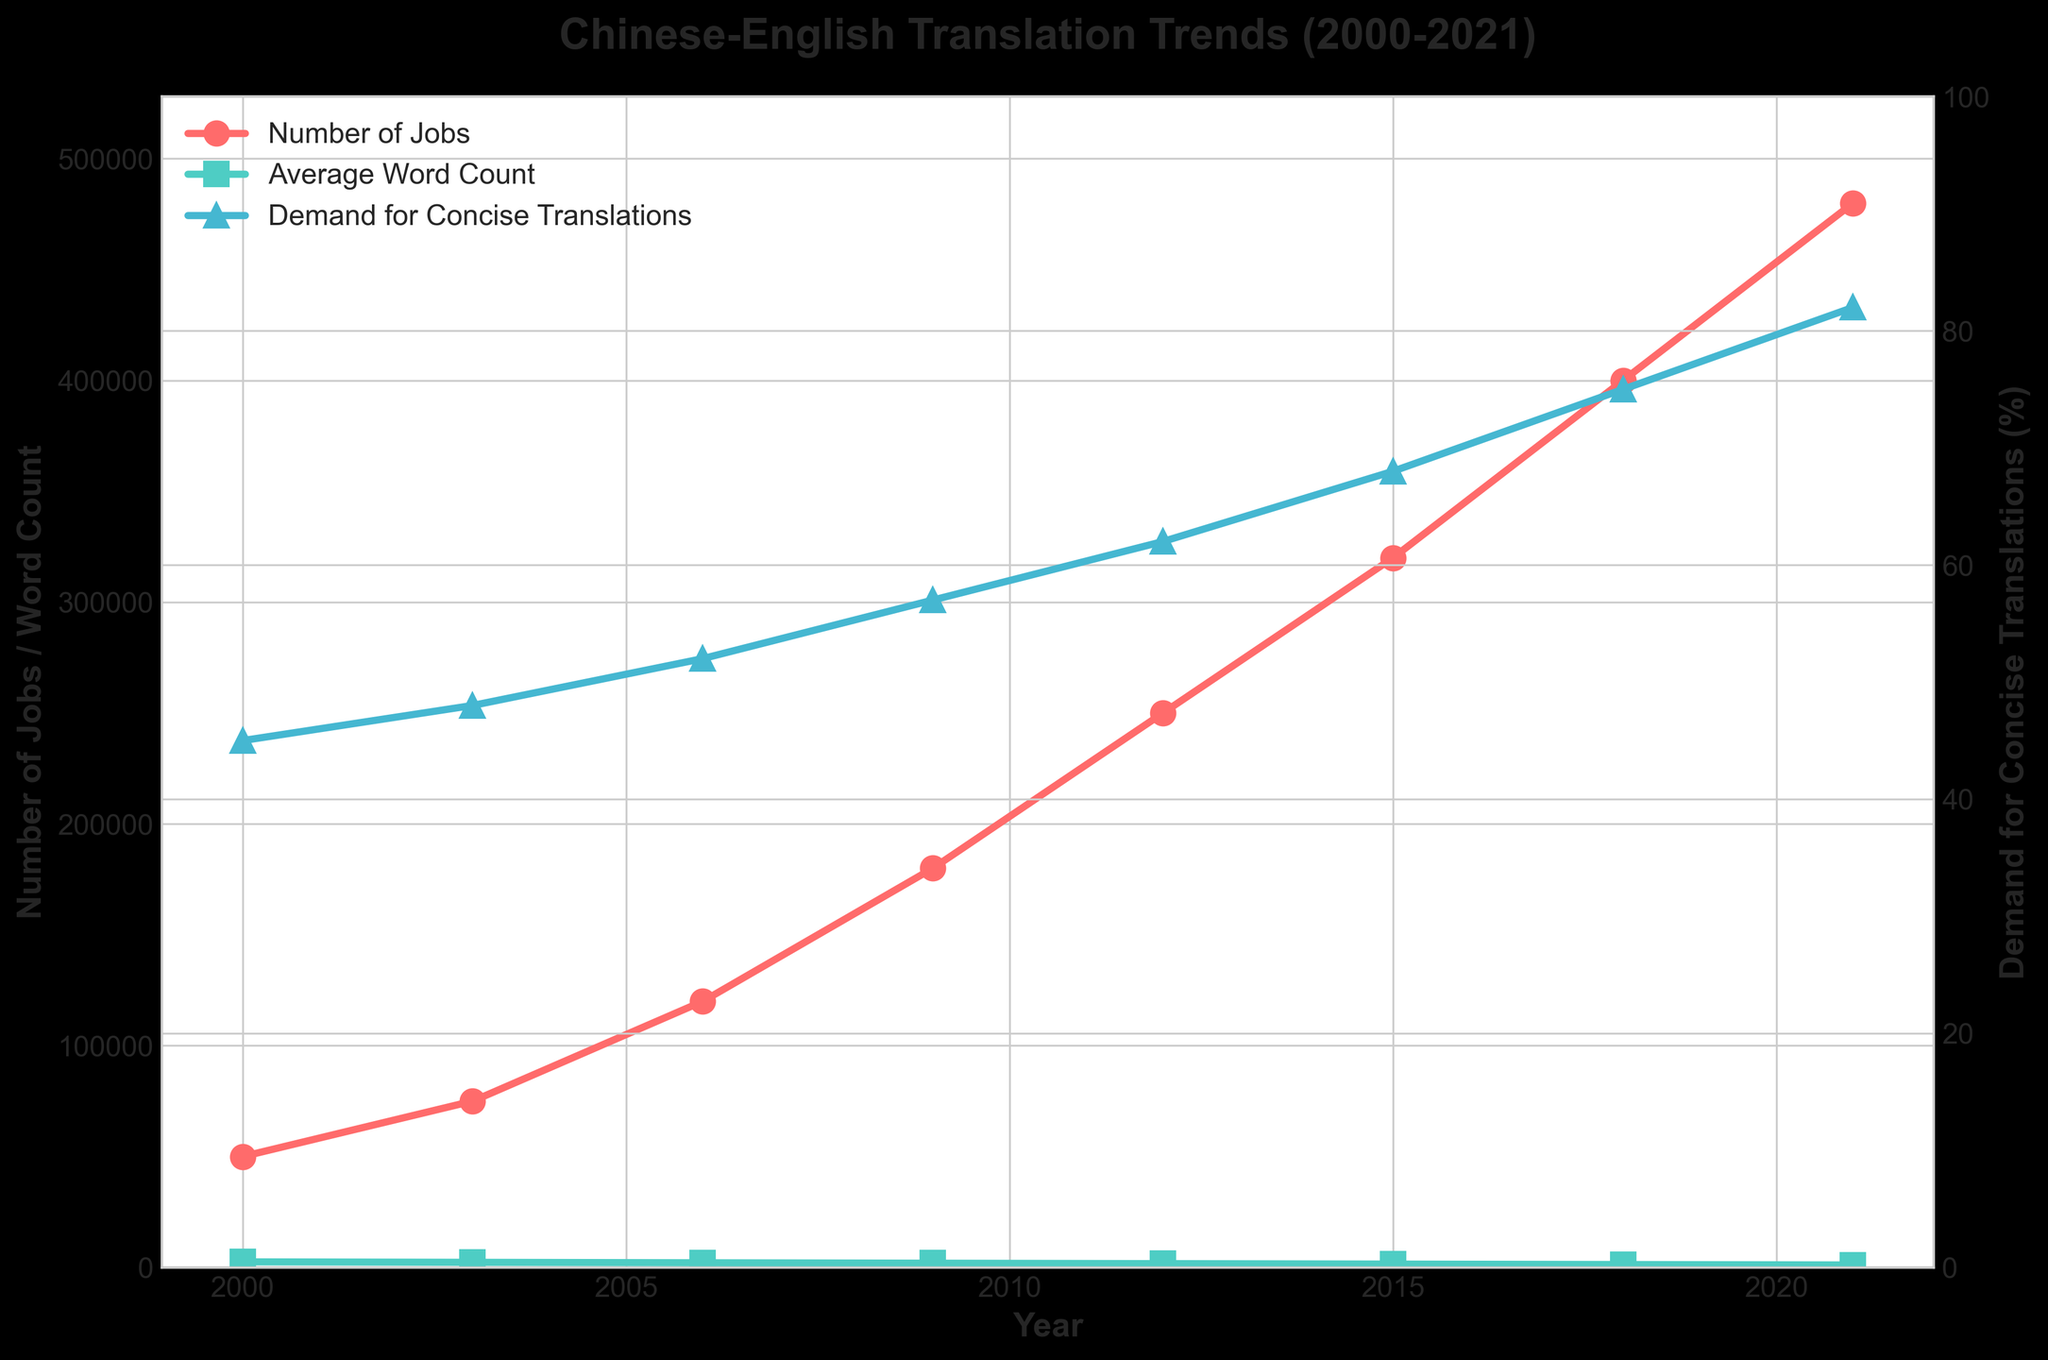What trend is observed in the number of Chinese-English translation jobs from 2000 to 2021? The number of Chinese-English translation jobs shows a consistent upward trend from 2000 (50,000 jobs) to 2021 (480,000 jobs), indicating a growing demand in this field over time.
Answer: Consistent upward trend How does the average word count per job change from 2000 to 2021? The average word count per job decreases consistently from 2500 words in 2000 to 1100 words in 2021, indicating a shift towards shorter translations over the years.
Answer: Decreases consistently What's the relationship between the number of jobs and the demand for concise translations (%) over the years? As the number of translation jobs increases, the demand for concise translations also increases. For instance, from 2000 to 2021, the number of jobs rose from 50,000 to 480,000, while the demand for concise translations increased from 45% to 82%.
Answer: Both increase Which year saw the highest increase in the number of Chinese-English translation jobs compared to the previous year? Comparing the years, the highest increase in the number of jobs is seen from 2006 to 2009, where it rose from 120,000 to 180,000, a difference of 60,000 jobs.
Answer: 2006 to 2009 By what percentage did the demand for concise translations increase from 2000 to 2021? The demand for concise translations increased from 45% in 2000 to 82% in 2021. The percentage increase can be calculated as \(\frac{82 - 45}{45} \times 100\%) = 82.22%.
Answer: 82.22% How does the average word count per job in 2021 compare to that in 2000? The average word count per job in 2021 (1100 words) is less than half of what it was in 2000 (2500 words), showing a significant reduction.
Answer: Less than half Which data series (jobs, word count, or concise translations demand) has the most dramatic change in its trend? The most dramatic change is observed in the number of Chinese-English translation jobs, which increased from 50,000 in 2000 to 480,000 in 2021, a nearly tenfold increase.
Answer: Number of jobs What can be inferred about the changing demands in the translation industry from this figure? The figure suggests increasing demand for translations (more jobs), a preference for shorter translations (declining word count), and a rising emphasis on conciseness in translations (increased demand for concise translations).
Answer: Increasing jobs, shorter translations, and higher emphasis on conciseness Which year marked the rapid ascension in the demand for concise translations above the 50% mark? The demand for concise translations crossed the 50% mark between 2006 (52%) and 2009 (57%), indicating a significant shift in preference towards concise translations during this period.
Answer: Between 2006 and 2009 What is the visual distinction used to differentiate the number of jobs and the average word count per job in the plot? The number of jobs is represented by a red line with circular markers, whereas the average word count per job is represented by a green line with square markers, making it easy to distinguish between the two trends visually.
Answer: Red line with circles (jobs), Green line with squares (word count) 